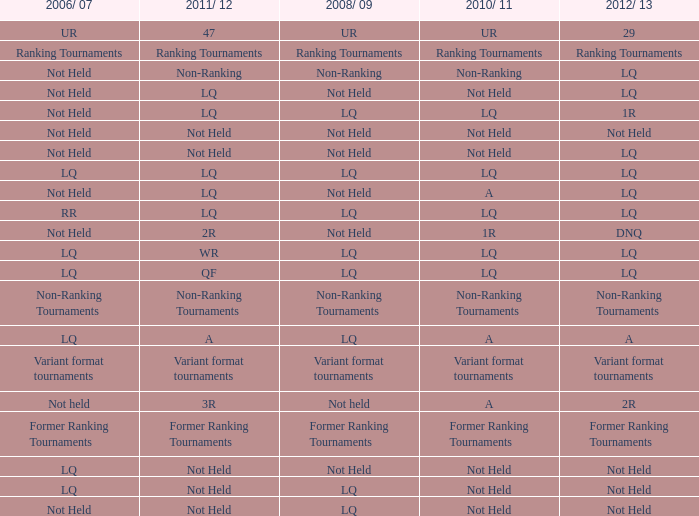What is 2010-11, when 2006/07 is UR? UR. 